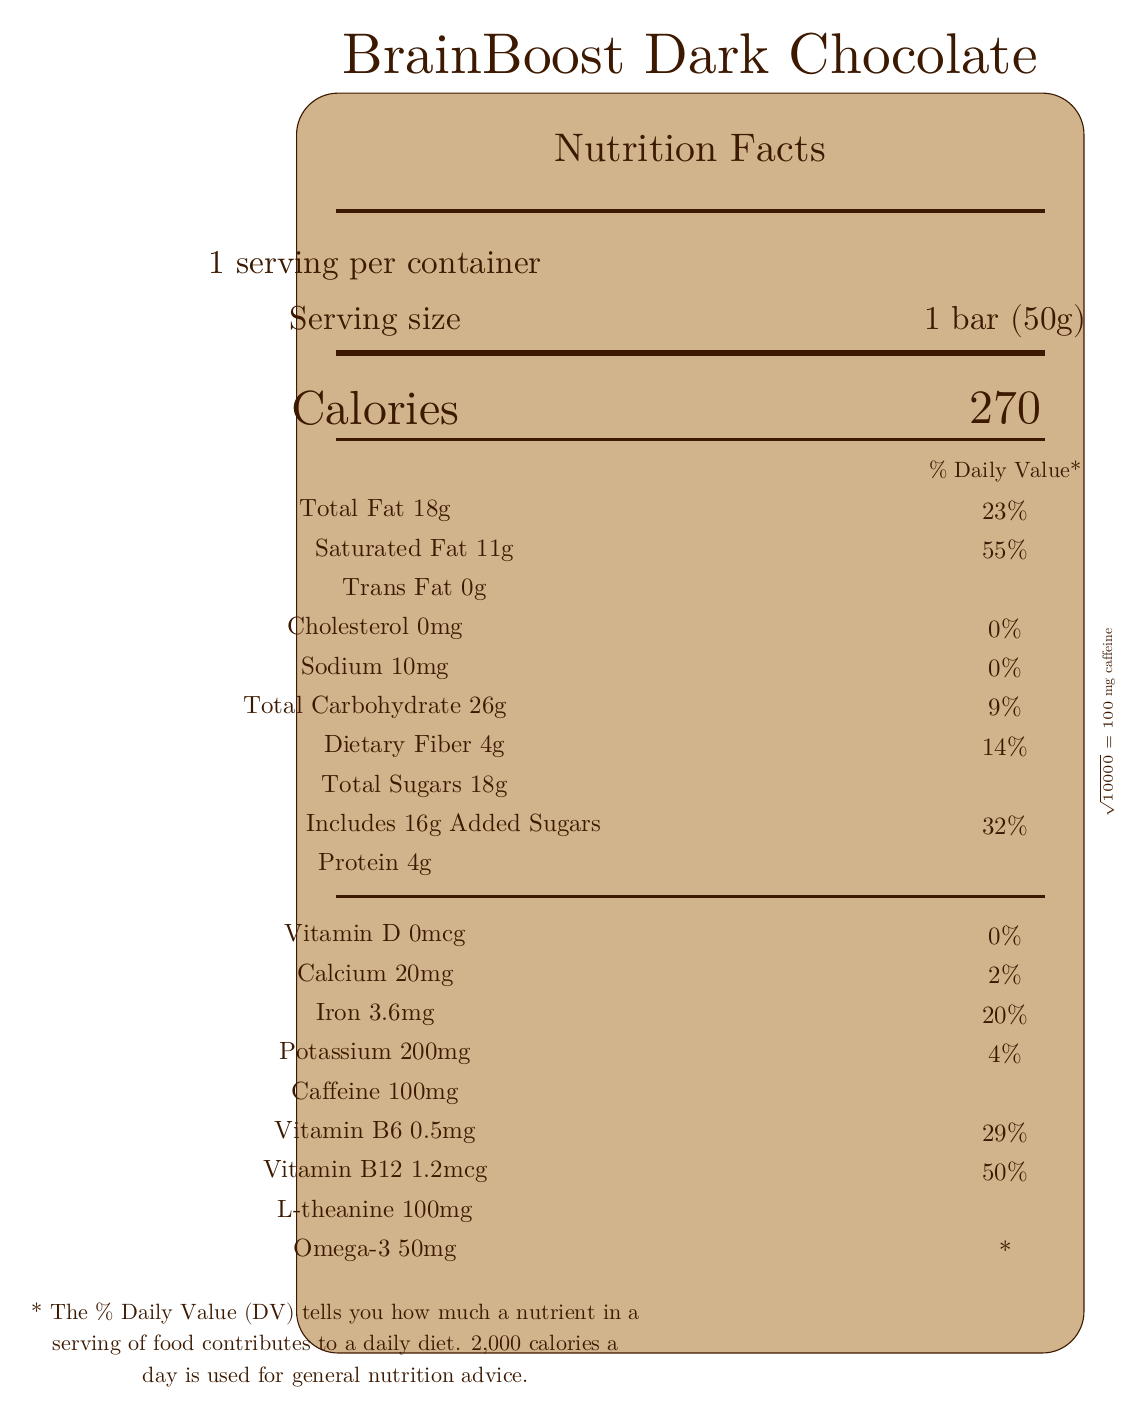What is the serving size of the BrainBoost Dark Chocolate bar? The serving size is directly specified as "1 bar (50g)" in the document.
Answer: 1 bar (50g) How many total calories are in one serving? The document states that there are 270 calories per serving.
Answer: 270 What is the amount of caffeine in one serving of the chocolate bar? The amount of caffeine in one serving is listed as 100mg.
Answer: 100mg What percentage of the daily value is the saturated fat content in one serving? The saturated fat content contributes 55% of the daily value.
Answer: 55% How much protein does one serving of the chocolate bar contain? The amount of protein is stated as 4g.
Answer: 4g Which vitamin in the chocolate bar has the highest daily value percentage? A. Vitamin D B. Calcium C. Iron D. Vitamin B6 E. Vitamin B12 Vitamin B12 has the highest daily value percentage at 50%.
Answer: E What nutrient in the chocolate bar helps with mental focus and cognitive performance, according to the claim statements? A. Vitamin D B. Calcium C. Omega-3 D. Vitamin B12 The claim statements mention that Vitamin B12 supports brain function.
Answer: D True or False: The BrainBoost Dark Chocolate contains milk. The document lists "May contain traces of milk," but does not confirm that it contains milk.
Answer: False Summarize the main idea of the document. The document is a Nutrition Facts Label for the BrainBoost Dark Chocolate bar, detailing its nutritional content and claims about cognitive benefits.
Answer: The document provides the nutritional facts for the BrainBoost Dark Chocolate bar. It includes information on serving size, calorie count, macronutrients, vitamins, minerals, and special ingredients like caffeine, theanine, and omega-3s. The label also lists claim statements related to mental focus and cognitive performance and provides allergen information. How many grams of dietary fiber are in one serving of the chocolate bar? The dietary fiber content is 4g per serving.
Answer: 4g What is the daily value percentage for added sugars in one serving? The added sugars contribute 32% of the daily value.
Answer: 32% Can we determine the exact amount of natural vanilla flavor in the ingredients? The document lists "natural vanilla flavor" as part of the ingredients, but does not specify the exact amount.
Answer: Not enough information What is the ratio of omega-3 content to caffeine content in the chocolate bar, according to the mathematician's note? The omega-3 content (50mg) is half the caffeine content (100mg), forming a 1:2 ratio.
Answer: 1:2 What are the two substances listed for potentially enhancing mental focus in the chocolate bar? The document specifies caffeine and theanine among the ingredients to enhance mental focus.
Answer: Caffeine and Theanine Does the BrainBoost Dark Chocolate bar contain trans fat? The document clearly states that the chocolate bar contains 0g of trans fat.
Answer: No 